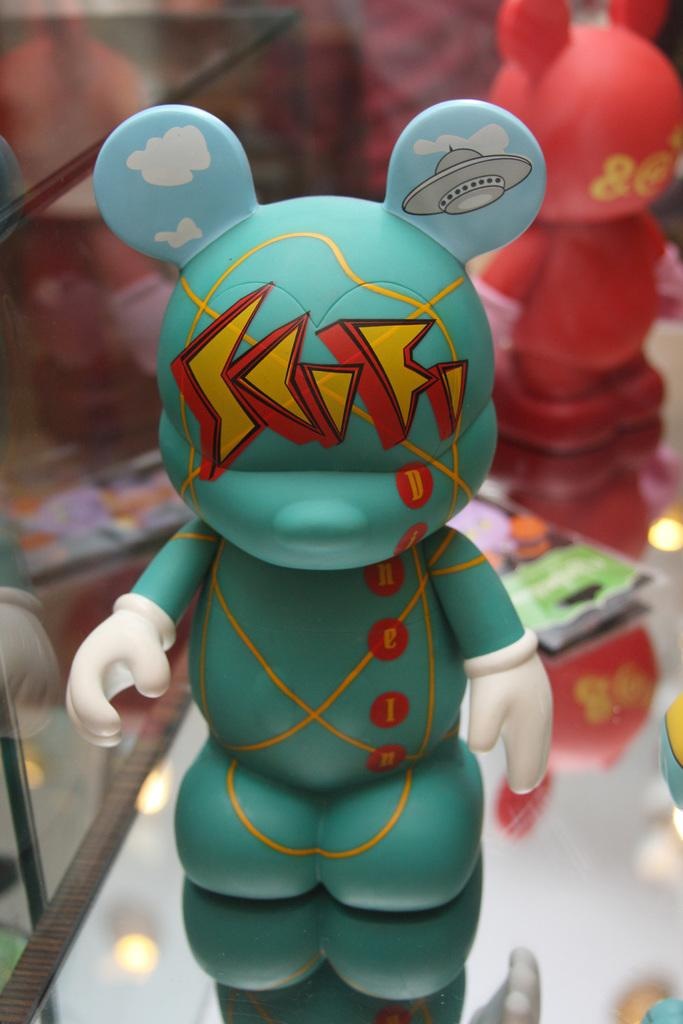What is the main object in the image? There is a toy in the image. What colors can be seen on the toy? The toy has green and red colors. Are there any other toys visible in the image? Yes, there are other toys in the background of the image. What can be said about the colors of the background toys? The background toys have multiple colors. What type of metal is used to make the bit for the horses in the image? There are no horses or bits present in the image, so it is not possible to determine the type of metal used. 